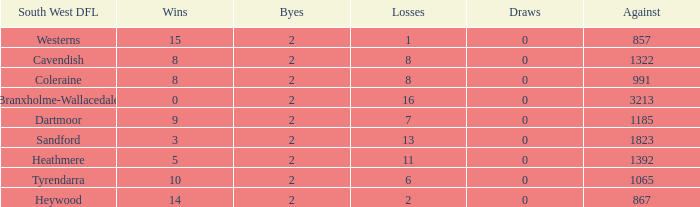Which draws have an average of 14 wins? 0.0. 